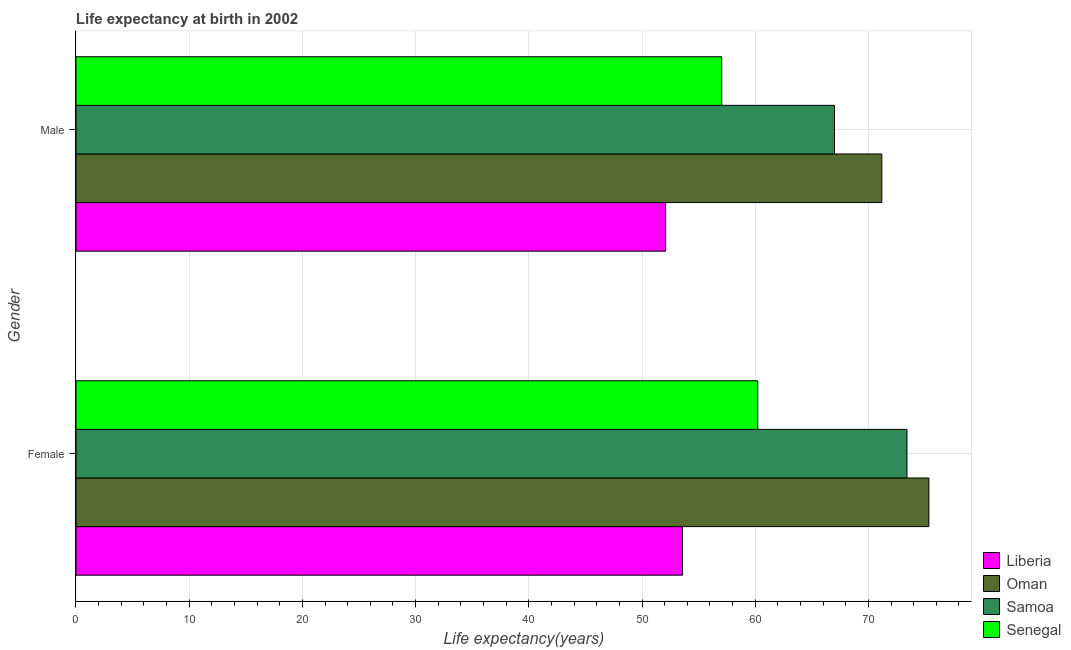How many different coloured bars are there?
Offer a terse response. 4. Are the number of bars on each tick of the Y-axis equal?
Give a very brief answer. Yes. How many bars are there on the 1st tick from the top?
Ensure brevity in your answer.  4. What is the label of the 2nd group of bars from the top?
Offer a terse response. Female. What is the life expectancy(female) in Senegal?
Provide a succinct answer. 60.23. Across all countries, what is the maximum life expectancy(female)?
Offer a very short reply. 75.34. Across all countries, what is the minimum life expectancy(female)?
Offer a very short reply. 53.58. In which country was the life expectancy(female) maximum?
Offer a terse response. Oman. In which country was the life expectancy(female) minimum?
Provide a succinct answer. Liberia. What is the total life expectancy(male) in the graph?
Offer a very short reply. 247.32. What is the difference between the life expectancy(male) in Senegal and that in Samoa?
Provide a short and direct response. -9.96. What is the difference between the life expectancy(male) in Samoa and the life expectancy(female) in Senegal?
Your answer should be compact. 6.78. What is the average life expectancy(female) per country?
Your answer should be compact. 65.64. What is the difference between the life expectancy(female) and life expectancy(male) in Oman?
Provide a short and direct response. 4.16. What is the ratio of the life expectancy(female) in Oman to that in Samoa?
Keep it short and to the point. 1.03. In how many countries, is the life expectancy(female) greater than the average life expectancy(female) taken over all countries?
Your answer should be compact. 2. What does the 1st bar from the top in Female represents?
Offer a terse response. Senegal. What does the 4th bar from the bottom in Female represents?
Provide a short and direct response. Senegal. How many countries are there in the graph?
Offer a very short reply. 4. Are the values on the major ticks of X-axis written in scientific E-notation?
Give a very brief answer. No. Does the graph contain any zero values?
Offer a very short reply. No. Where does the legend appear in the graph?
Ensure brevity in your answer.  Bottom right. How many legend labels are there?
Give a very brief answer. 4. What is the title of the graph?
Provide a succinct answer. Life expectancy at birth in 2002. What is the label or title of the X-axis?
Your answer should be very brief. Life expectancy(years). What is the Life expectancy(years) in Liberia in Female?
Provide a short and direct response. 53.58. What is the Life expectancy(years) of Oman in Female?
Offer a terse response. 75.34. What is the Life expectancy(years) in Samoa in Female?
Give a very brief answer. 73.41. What is the Life expectancy(years) in Senegal in Female?
Provide a short and direct response. 60.23. What is the Life expectancy(years) of Liberia in Male?
Your answer should be compact. 52.08. What is the Life expectancy(years) of Oman in Male?
Your answer should be compact. 71.19. What is the Life expectancy(years) in Samoa in Male?
Offer a terse response. 67. What is the Life expectancy(years) in Senegal in Male?
Provide a succinct answer. 57.04. Across all Gender, what is the maximum Life expectancy(years) of Liberia?
Ensure brevity in your answer.  53.58. Across all Gender, what is the maximum Life expectancy(years) of Oman?
Give a very brief answer. 75.34. Across all Gender, what is the maximum Life expectancy(years) in Samoa?
Your response must be concise. 73.41. Across all Gender, what is the maximum Life expectancy(years) in Senegal?
Offer a terse response. 60.23. Across all Gender, what is the minimum Life expectancy(years) of Liberia?
Make the answer very short. 52.08. Across all Gender, what is the minimum Life expectancy(years) of Oman?
Ensure brevity in your answer.  71.19. Across all Gender, what is the minimum Life expectancy(years) in Samoa?
Give a very brief answer. 67. Across all Gender, what is the minimum Life expectancy(years) in Senegal?
Your response must be concise. 57.04. What is the total Life expectancy(years) in Liberia in the graph?
Offer a terse response. 105.66. What is the total Life expectancy(years) of Oman in the graph?
Provide a short and direct response. 146.53. What is the total Life expectancy(years) in Samoa in the graph?
Provide a short and direct response. 140.41. What is the total Life expectancy(years) of Senegal in the graph?
Your answer should be compact. 117.27. What is the difference between the Life expectancy(years) of Liberia in Female and that in Male?
Keep it short and to the point. 1.49. What is the difference between the Life expectancy(years) of Oman in Female and that in Male?
Make the answer very short. 4.16. What is the difference between the Life expectancy(years) of Samoa in Female and that in Male?
Offer a very short reply. 6.4. What is the difference between the Life expectancy(years) in Senegal in Female and that in Male?
Your response must be concise. 3.18. What is the difference between the Life expectancy(years) of Liberia in Female and the Life expectancy(years) of Oman in Male?
Give a very brief answer. -17.61. What is the difference between the Life expectancy(years) in Liberia in Female and the Life expectancy(years) in Samoa in Male?
Provide a short and direct response. -13.43. What is the difference between the Life expectancy(years) of Liberia in Female and the Life expectancy(years) of Senegal in Male?
Give a very brief answer. -3.47. What is the difference between the Life expectancy(years) in Oman in Female and the Life expectancy(years) in Samoa in Male?
Your response must be concise. 8.34. What is the difference between the Life expectancy(years) in Oman in Female and the Life expectancy(years) in Senegal in Male?
Give a very brief answer. 18.3. What is the difference between the Life expectancy(years) of Samoa in Female and the Life expectancy(years) of Senegal in Male?
Ensure brevity in your answer.  16.36. What is the average Life expectancy(years) of Liberia per Gender?
Give a very brief answer. 52.83. What is the average Life expectancy(years) of Oman per Gender?
Provide a succinct answer. 73.26. What is the average Life expectancy(years) in Samoa per Gender?
Your response must be concise. 70.21. What is the average Life expectancy(years) of Senegal per Gender?
Make the answer very short. 58.63. What is the difference between the Life expectancy(years) of Liberia and Life expectancy(years) of Oman in Female?
Your answer should be very brief. -21.77. What is the difference between the Life expectancy(years) of Liberia and Life expectancy(years) of Samoa in Female?
Provide a short and direct response. -19.83. What is the difference between the Life expectancy(years) of Liberia and Life expectancy(years) of Senegal in Female?
Your response must be concise. -6.65. What is the difference between the Life expectancy(years) in Oman and Life expectancy(years) in Samoa in Female?
Provide a short and direct response. 1.93. What is the difference between the Life expectancy(years) of Oman and Life expectancy(years) of Senegal in Female?
Offer a terse response. 15.12. What is the difference between the Life expectancy(years) in Samoa and Life expectancy(years) in Senegal in Female?
Provide a succinct answer. 13.18. What is the difference between the Life expectancy(years) in Liberia and Life expectancy(years) in Oman in Male?
Offer a terse response. -19.1. What is the difference between the Life expectancy(years) of Liberia and Life expectancy(years) of Samoa in Male?
Provide a succinct answer. -14.92. What is the difference between the Life expectancy(years) of Liberia and Life expectancy(years) of Senegal in Male?
Your answer should be compact. -4.96. What is the difference between the Life expectancy(years) in Oman and Life expectancy(years) in Samoa in Male?
Provide a succinct answer. 4.18. What is the difference between the Life expectancy(years) of Oman and Life expectancy(years) of Senegal in Male?
Ensure brevity in your answer.  14.14. What is the difference between the Life expectancy(years) in Samoa and Life expectancy(years) in Senegal in Male?
Provide a short and direct response. 9.96. What is the ratio of the Life expectancy(years) of Liberia in Female to that in Male?
Offer a very short reply. 1.03. What is the ratio of the Life expectancy(years) in Oman in Female to that in Male?
Give a very brief answer. 1.06. What is the ratio of the Life expectancy(years) in Samoa in Female to that in Male?
Make the answer very short. 1.1. What is the ratio of the Life expectancy(years) in Senegal in Female to that in Male?
Offer a very short reply. 1.06. What is the difference between the highest and the second highest Life expectancy(years) of Liberia?
Your answer should be compact. 1.49. What is the difference between the highest and the second highest Life expectancy(years) in Oman?
Give a very brief answer. 4.16. What is the difference between the highest and the second highest Life expectancy(years) in Samoa?
Offer a terse response. 6.4. What is the difference between the highest and the second highest Life expectancy(years) in Senegal?
Offer a terse response. 3.18. What is the difference between the highest and the lowest Life expectancy(years) in Liberia?
Your answer should be very brief. 1.49. What is the difference between the highest and the lowest Life expectancy(years) in Oman?
Your response must be concise. 4.16. What is the difference between the highest and the lowest Life expectancy(years) of Samoa?
Offer a terse response. 6.4. What is the difference between the highest and the lowest Life expectancy(years) of Senegal?
Your response must be concise. 3.18. 